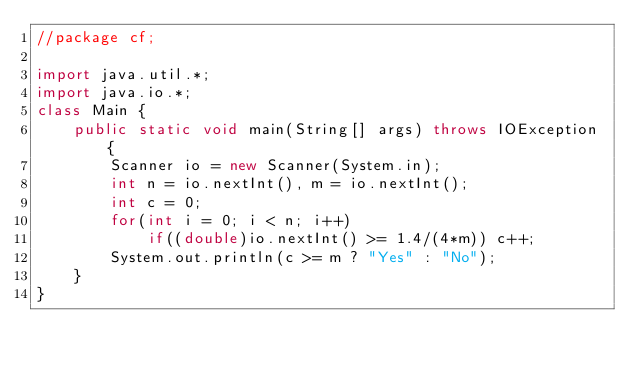<code> <loc_0><loc_0><loc_500><loc_500><_Java_>//package cf;

import java.util.*;
import java.io.*;
class Main {
    public static void main(String[] args) throws IOException {
        Scanner io = new Scanner(System.in);
        int n = io.nextInt(), m = io.nextInt();
        int c = 0;
        for(int i = 0; i < n; i++)
            if((double)io.nextInt() >= 1.4/(4*m)) c++;
        System.out.println(c >= m ? "Yes" : "No");
    }
}


</code> 